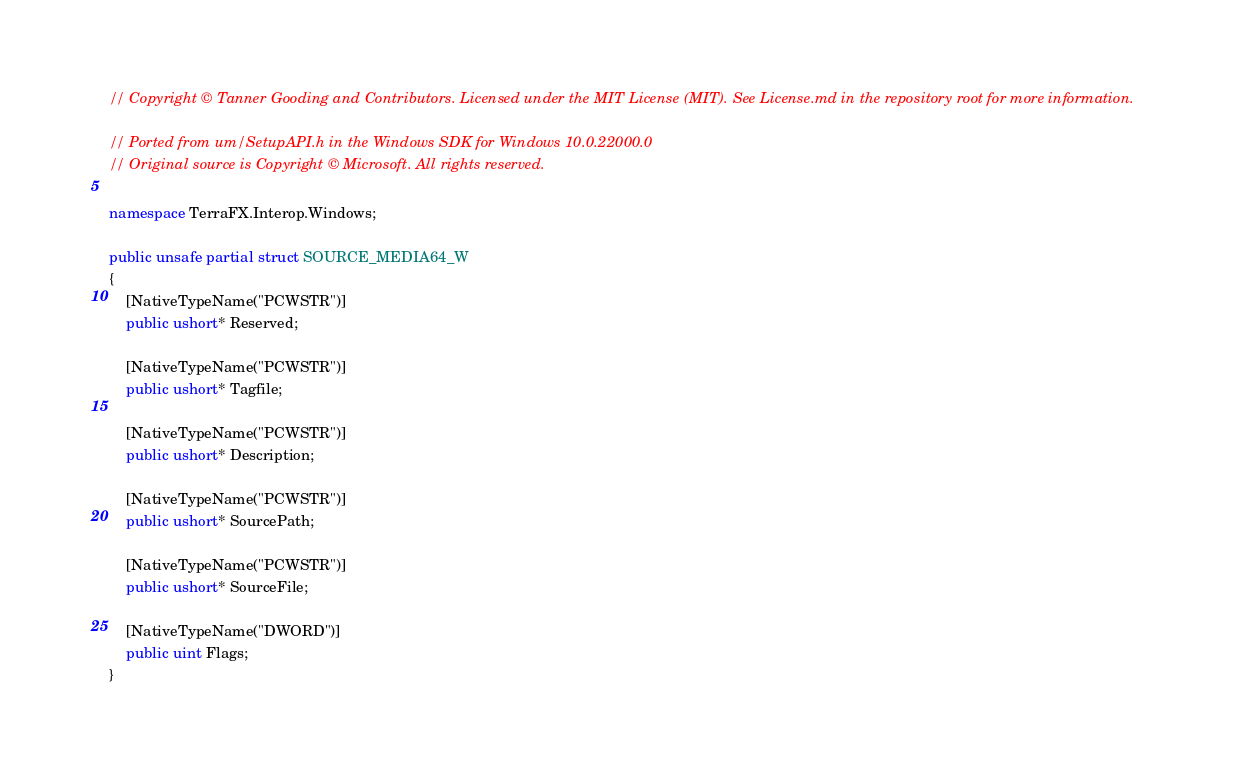Convert code to text. <code><loc_0><loc_0><loc_500><loc_500><_C#_>// Copyright © Tanner Gooding and Contributors. Licensed under the MIT License (MIT). See License.md in the repository root for more information.

// Ported from um/SetupAPI.h in the Windows SDK for Windows 10.0.22000.0
// Original source is Copyright © Microsoft. All rights reserved.

namespace TerraFX.Interop.Windows;

public unsafe partial struct SOURCE_MEDIA64_W
{
    [NativeTypeName("PCWSTR")]
    public ushort* Reserved;

    [NativeTypeName("PCWSTR")]
    public ushort* Tagfile;

    [NativeTypeName("PCWSTR")]
    public ushort* Description;

    [NativeTypeName("PCWSTR")]
    public ushort* SourcePath;

    [NativeTypeName("PCWSTR")]
    public ushort* SourceFile;

    [NativeTypeName("DWORD")]
    public uint Flags;
}
</code> 